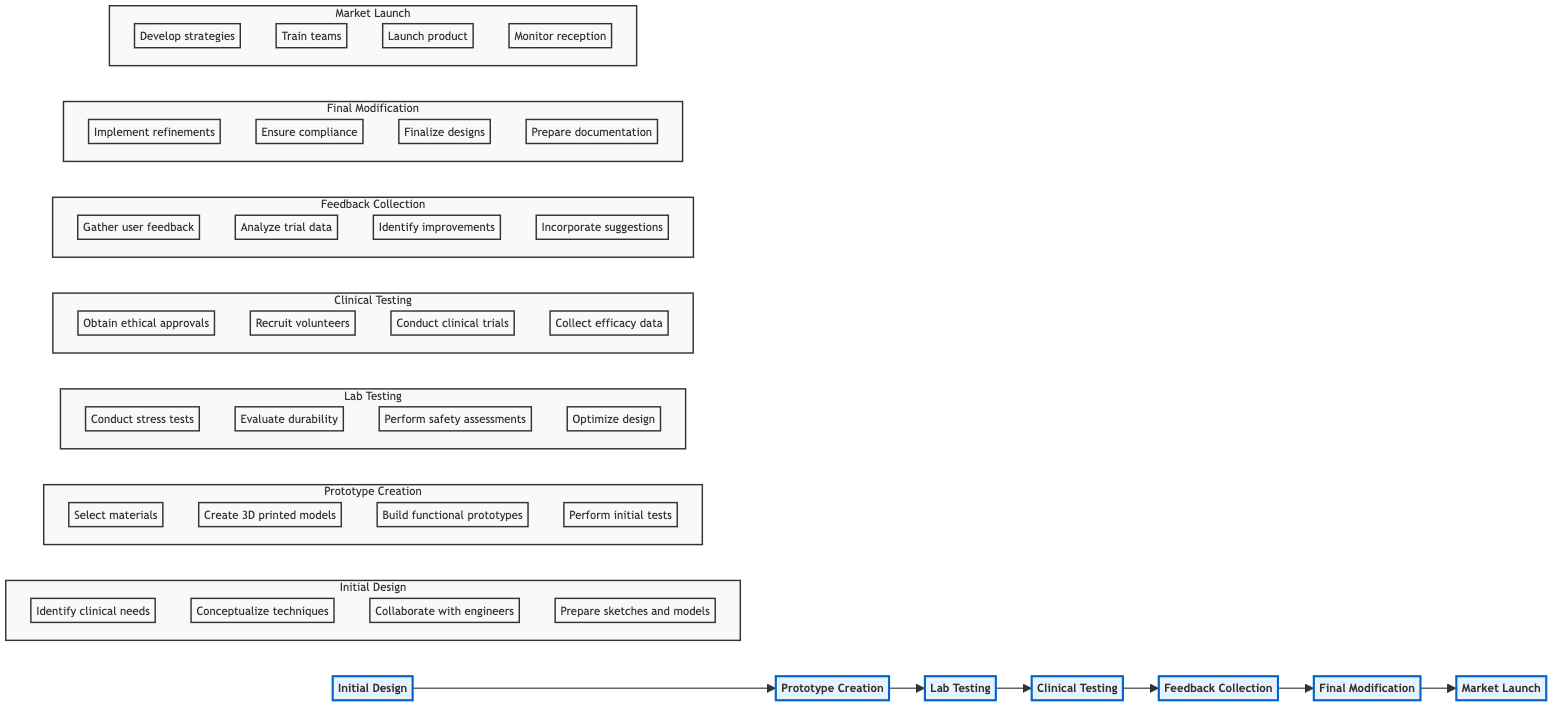What is the first step in the flowchart? The first step is indicated as "Initial Design," which is the starting point of the process in the diagram.
Answer: Initial Design How many phases are present in the flowchart? By counting the nodes in the diagram, we see there are seven distinct phases: Initial Design, Prototype Creation, Lab Testing, Clinical Testing, Feedback Collection, Final Modification, and Market Launch.
Answer: Seven What is the last step before Market Launch? The last step before Market Launch is "Final Modification," which precedes the market introduction as indicated in the flowchart.
Answer: Final Modification Which step involves recruiting patient volunteers? The step that involves recruiting patient volunteers is "Clinical Testing," which specifically mentions this task as one of its actions.
Answer: Clinical Testing What phase immediately follows Lab Testing? Following Lab Testing in the flowchart is Clinical Testing, as there is a direct arrow showing the progression to this phase.
Answer: Clinical Testing What is the main activity of the Feedback Collection phase? The main activity in the Feedback Collection phase is to gather feedback from therapists and patients, as outlined in the flowchart description.
Answer: Gather feedback Which phase requires ethical approvals? The phase that requires obtaining ethical approvals is "Clinical Testing," as it is crucial for the ethical conduct of trials involving human subjects.
Answer: Clinical Testing How many steps are there in the Final Modification phase? The Final Modification phase consists of four steps as per the subgraph structure reflecting its detailed breakdown in the flowchart.
Answer: Four What comes after Gathering user feedback? After Gathering user feedback, the next step is analyzing trial data and user experiences, demonstrating the iterative nature of the process.
Answer: Analyze trial data and user experiences 